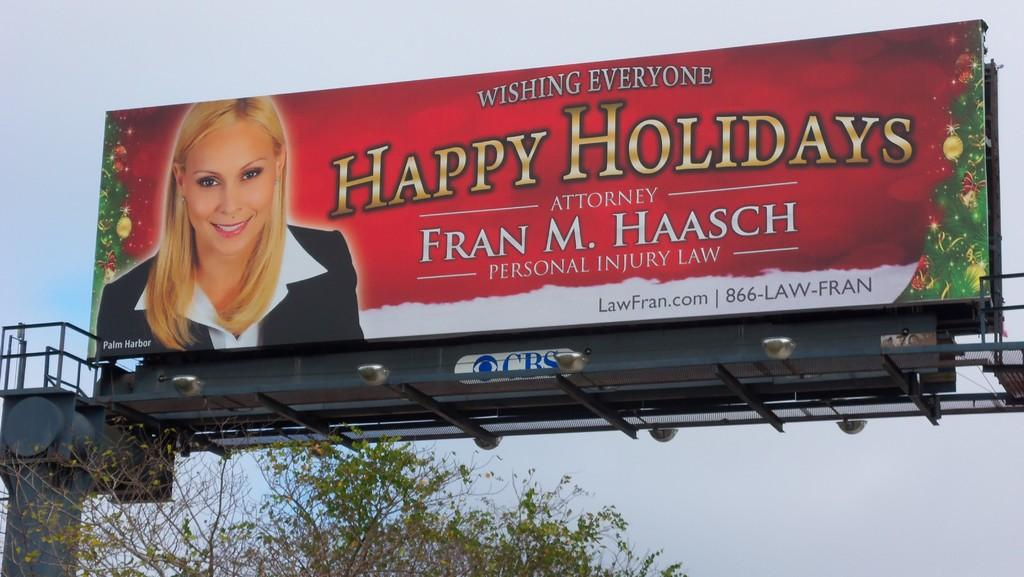<image>
Provide a brief description of the given image. A billboard for Attorney Fran M. Haasch wishing everyone happy holidays. 